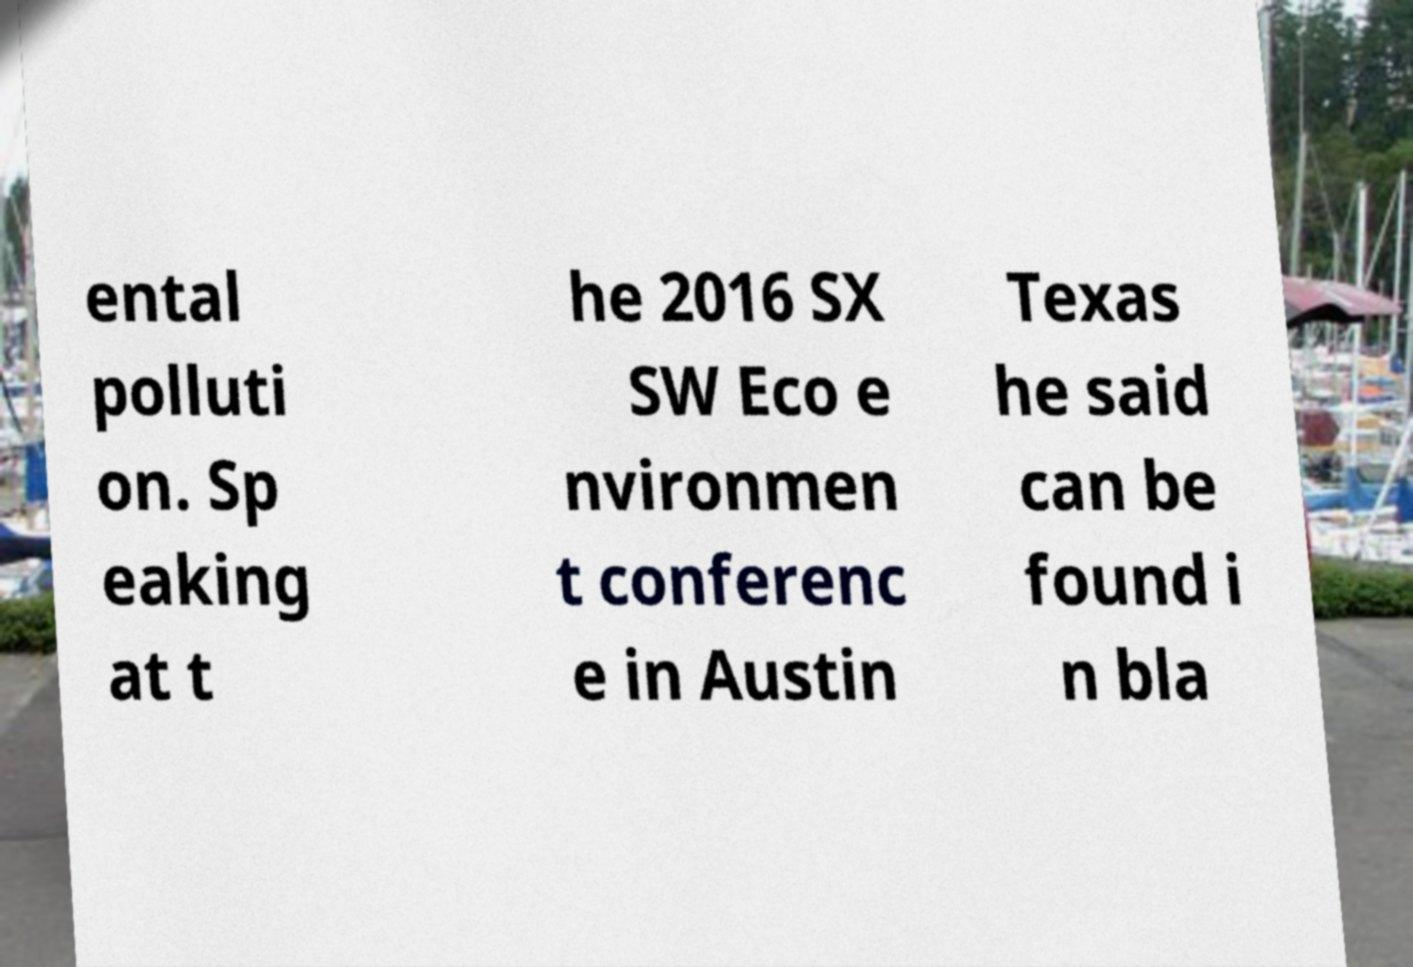For documentation purposes, I need the text within this image transcribed. Could you provide that? ental polluti on. Sp eaking at t he 2016 SX SW Eco e nvironmen t conferenc e in Austin Texas he said can be found i n bla 